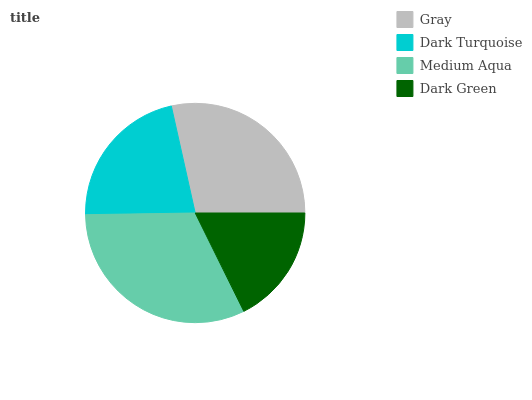Is Dark Green the minimum?
Answer yes or no. Yes. Is Medium Aqua the maximum?
Answer yes or no. Yes. Is Dark Turquoise the minimum?
Answer yes or no. No. Is Dark Turquoise the maximum?
Answer yes or no. No. Is Gray greater than Dark Turquoise?
Answer yes or no. Yes. Is Dark Turquoise less than Gray?
Answer yes or no. Yes. Is Dark Turquoise greater than Gray?
Answer yes or no. No. Is Gray less than Dark Turquoise?
Answer yes or no. No. Is Gray the high median?
Answer yes or no. Yes. Is Dark Turquoise the low median?
Answer yes or no. Yes. Is Dark Green the high median?
Answer yes or no. No. Is Medium Aqua the low median?
Answer yes or no. No. 